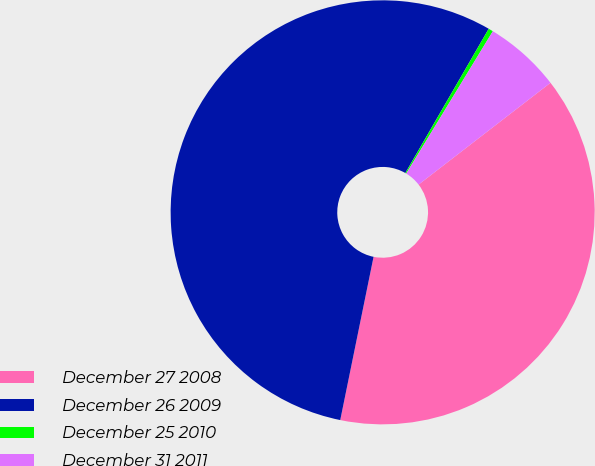<chart> <loc_0><loc_0><loc_500><loc_500><pie_chart><fcel>December 27 2008<fcel>December 26 2009<fcel>December 25 2010<fcel>December 31 2011<nl><fcel>38.67%<fcel>55.14%<fcel>0.36%<fcel>5.84%<nl></chart> 